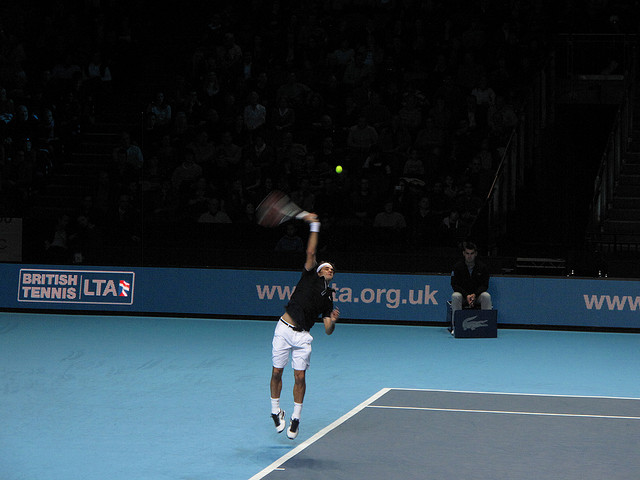Read and extract the text from this image. BRITISH TENNIS LTA www 